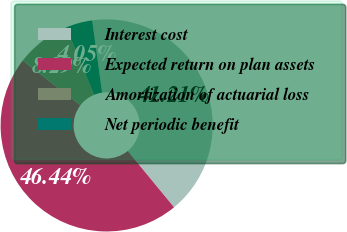Convert chart. <chart><loc_0><loc_0><loc_500><loc_500><pie_chart><fcel>Interest cost<fcel>Expected return on plan assets<fcel>Amortization of actuarial loss<fcel>Net periodic benefit<nl><fcel>41.21%<fcel>46.44%<fcel>8.29%<fcel>4.05%<nl></chart> 